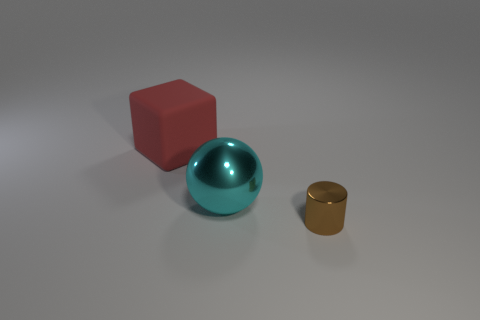There is a thing that is on the right side of the cyan metal ball; what is it made of?
Your answer should be compact. Metal. Is the object that is in front of the cyan object made of the same material as the red thing?
Give a very brief answer. No. Are any big yellow shiny things visible?
Your answer should be compact. No. There is a large thing that is the same material as the tiny brown cylinder; what color is it?
Give a very brief answer. Cyan. There is a shiny thing that is left of the object right of the big thing that is on the right side of the large red thing; what is its color?
Offer a terse response. Cyan. There is a red cube; does it have the same size as the metallic thing left of the tiny brown shiny cylinder?
Give a very brief answer. Yes. What number of things are either things that are to the right of the large red cube or things behind the cylinder?
Your answer should be very brief. 3. There is a red rubber thing that is the same size as the cyan metal sphere; what is its shape?
Your answer should be very brief. Cube. The big thing on the right side of the big object that is on the left side of the large thing that is in front of the big red cube is what shape?
Your response must be concise. Sphere. Are there an equal number of big objects that are on the right side of the tiny object and red matte cubes?
Provide a succinct answer. No. 